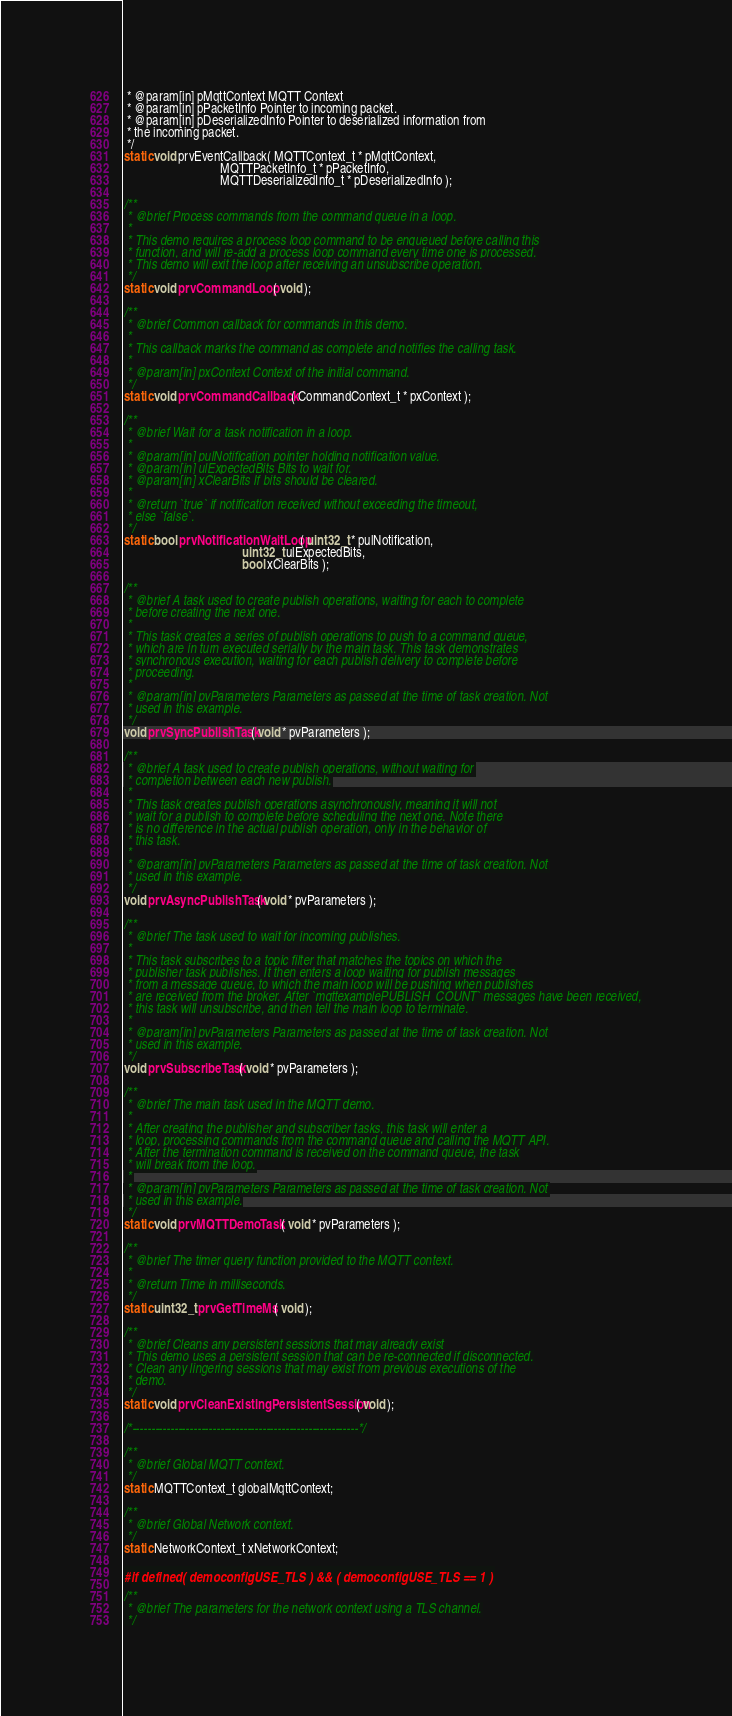<code> <loc_0><loc_0><loc_500><loc_500><_C_> * @param[in] pMqttContext MQTT Context
 * @param[in] pPacketInfo Pointer to incoming packet.
 * @param[in] pDeserializedInfo Pointer to deserialized information from
 * the incoming packet.
 */
static void prvEventCallback( MQTTContext_t * pMqttContext,
                              MQTTPacketInfo_t * pPacketInfo,
                              MQTTDeserializedInfo_t * pDeserializedInfo );

/**
 * @brief Process commands from the command queue in a loop.
 *
 * This demo requires a process loop command to be enqueued before calling this
 * function, and will re-add a process loop command every time one is processed.
 * This demo will exit the loop after receiving an unsubscribe operation.
 */
static void prvCommandLoop( void );

/**
 * @brief Common callback for commands in this demo.
 *
 * This callback marks the command as complete and notifies the calling task.
 *
 * @param[in] pxContext Context of the initial command.
 */
static void prvCommandCallback( CommandContext_t * pxContext );

/**
 * @brief Wait for a task notification in a loop.
 *
 * @param[in] pulNotification pointer holding notification value.
 * @param[in] ulExpectedBits Bits to wait for.
 * @param[in] xClearBits If bits should be cleared.
 *
 * @return `true` if notification received without exceeding the timeout,
 * else `false`.
 */
static bool prvNotificationWaitLoop( uint32_t * pulNotification,
                                     uint32_t ulExpectedBits,
                                     bool xClearBits );

/**
 * @brief A task used to create publish operations, waiting for each to complete
 * before creating the next one.
 *
 * This task creates a series of publish operations to push to a command queue,
 * which are in turn executed serially by the main task. This task demonstrates
 * synchronous execution, waiting for each publish delivery to complete before
 * proceeding.
 *
 * @param[in] pvParameters Parameters as passed at the time of task creation. Not
 * used in this example.
 */
void prvSyncPublishTask( void * pvParameters );

/**
 * @brief A task used to create publish operations, without waiting for
 * completion between each new publish.
 *
 * This task creates publish operations asynchronously, meaning it will not
 * wait for a publish to complete before scheduling the next one. Note there
 * is no difference in the actual publish operation, only in the behavior of
 * this task.
 *
 * @param[in] pvParameters Parameters as passed at the time of task creation. Not
 * used in this example.
 */
void prvAsyncPublishTask( void * pvParameters );

/**
 * @brief The task used to wait for incoming publishes.
 *
 * This task subscribes to a topic filter that matches the topics on which the
 * publisher task publishes. It then enters a loop waiting for publish messages
 * from a message queue, to which the main loop will be pushing when publishes
 * are received from the broker. After `mqttexamplePUBLISH_COUNT` messages have been received,
 * this task will unsubscribe, and then tell the main loop to terminate.
 *
 * @param[in] pvParameters Parameters as passed at the time of task creation. Not
 * used in this example.
 */
void prvSubscribeTask( void * pvParameters );

/**
 * @brief The main task used in the MQTT demo.
 *
 * After creating the publisher and subscriber tasks, this task will enter a
 * loop, processing commands from the command queue and calling the MQTT API.
 * After the termination command is received on the command queue, the task
 * will break from the loop.
 *
 * @param[in] pvParameters Parameters as passed at the time of task creation. Not
 * used in this example.
 */
static void prvMQTTDemoTask( void * pvParameters );

/**
 * @brief The timer query function provided to the MQTT context.
 *
 * @return Time in milliseconds.
 */
static uint32_t prvGetTimeMs( void );

/**
 * @brief Cleans any persistent sessions that may already exist
 * This demo uses a persistent session that can be re-connected if disconnected.
 * Clean any lingering sessions that may exist from previous executions of the
 * demo.
 */
static void prvCleanExistingPersistentSession( void );

/*-----------------------------------------------------------*/

/**
 * @brief Global MQTT context.
 */
static MQTTContext_t globalMqttContext;

/**
 * @brief Global Network context.
 */
static NetworkContext_t xNetworkContext;

#if defined( democonfigUSE_TLS ) && ( democonfigUSE_TLS == 1 )

/**
 * @brief The parameters for the network context using a TLS channel.
 */</code> 